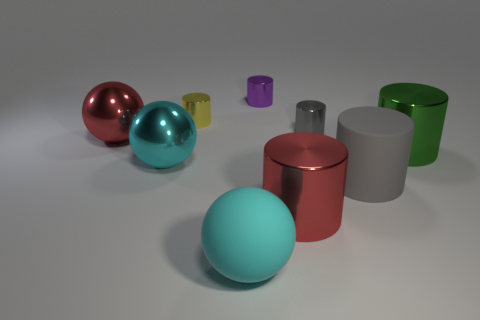Is there any other thing that has the same size as the green metal object?
Provide a short and direct response. Yes. There is a big red shiny object that is right of the metal sphere right of the red metal sphere that is to the left of the gray metallic cylinder; what shape is it?
Your answer should be very brief. Cylinder. What number of other objects are the same color as the large rubber cylinder?
Your answer should be very brief. 1. There is a cyan object that is behind the big gray matte cylinder that is in front of the big red sphere; what is its shape?
Keep it short and to the point. Sphere. What number of tiny metal objects are in front of the large rubber ball?
Provide a short and direct response. 0. Are there any large red spheres that have the same material as the tiny gray cylinder?
Ensure brevity in your answer.  Yes. There is a gray thing that is the same size as the red sphere; what is its material?
Give a very brief answer. Rubber. What size is the cylinder that is left of the gray metallic thing and in front of the small gray shiny object?
Ensure brevity in your answer.  Large. There is a large metallic object that is left of the tiny gray metallic object and on the right side of the big cyan rubber thing; what color is it?
Offer a very short reply. Red. Is the number of balls that are left of the cyan metallic object less than the number of cylinders that are left of the small purple metal cylinder?
Your answer should be very brief. No. 